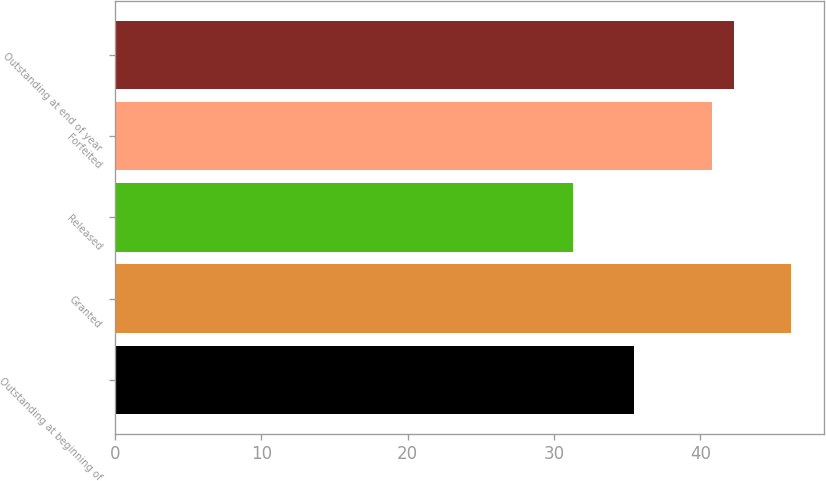Convert chart to OTSL. <chart><loc_0><loc_0><loc_500><loc_500><bar_chart><fcel>Outstanding at beginning of<fcel>Granted<fcel>Released<fcel>Forfeited<fcel>Outstanding at end of year<nl><fcel>35.43<fcel>46.17<fcel>31.28<fcel>40.79<fcel>42.28<nl></chart> 